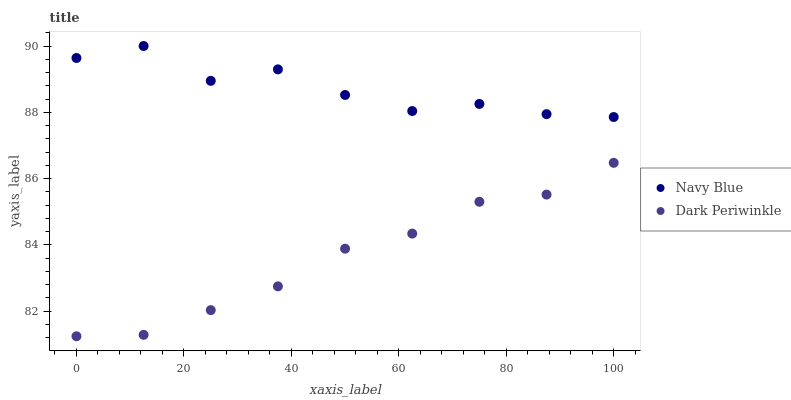Does Dark Periwinkle have the minimum area under the curve?
Answer yes or no. Yes. Does Navy Blue have the maximum area under the curve?
Answer yes or no. Yes. Does Dark Periwinkle have the maximum area under the curve?
Answer yes or no. No. Is Dark Periwinkle the smoothest?
Answer yes or no. Yes. Is Navy Blue the roughest?
Answer yes or no. Yes. Is Dark Periwinkle the roughest?
Answer yes or no. No. Does Dark Periwinkle have the lowest value?
Answer yes or no. Yes. Does Navy Blue have the highest value?
Answer yes or no. Yes. Does Dark Periwinkle have the highest value?
Answer yes or no. No. Is Dark Periwinkle less than Navy Blue?
Answer yes or no. Yes. Is Navy Blue greater than Dark Periwinkle?
Answer yes or no. Yes. Does Dark Periwinkle intersect Navy Blue?
Answer yes or no. No. 